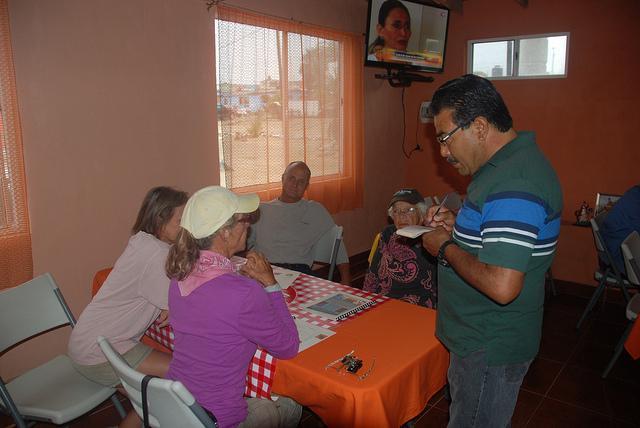How many people are seated?
Give a very brief answer. 4. How many people are at the table?
Give a very brief answer. 4. How many people are in this picture?
Give a very brief answer. 5. How many boys are in the photo?
Give a very brief answer. 2. How many bottles are on the table?
Give a very brief answer. 0. How many females are in the room?
Give a very brief answer. 3. How many chairs can be seen?
Give a very brief answer. 2. How many people are there?
Give a very brief answer. 5. How many sheep are there?
Give a very brief answer. 0. 